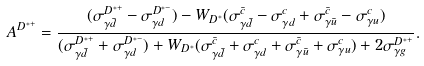Convert formula to latex. <formula><loc_0><loc_0><loc_500><loc_500>A ^ { D ^ { * + } } = \frac { ( \sigma ^ { D ^ { * + } } _ { \gamma \bar { d } } - \sigma ^ { D ^ { * - } } _ { \gamma d } ) - W _ { D ^ { * } } ( \sigma ^ { \bar { c } } _ { \gamma \bar { d } } - \sigma ^ { c } _ { \gamma d } + \sigma ^ { \bar { c } } _ { \gamma \bar { u } } - \sigma ^ { c } _ { \gamma u } ) } { ( \sigma ^ { D ^ { * + } } _ { \gamma \bar { d } } + \sigma ^ { D ^ { * - } } _ { \gamma d } ) + W _ { D ^ { * } } ( \sigma ^ { \bar { c } } _ { \gamma \bar { d } } + \sigma ^ { c } _ { \gamma d } + \sigma ^ { \bar { c } } _ { \gamma \bar { u } } + \sigma ^ { c } _ { \gamma u } ) + 2 \sigma ^ { D ^ { * + } } _ { \gamma g } } .</formula> 